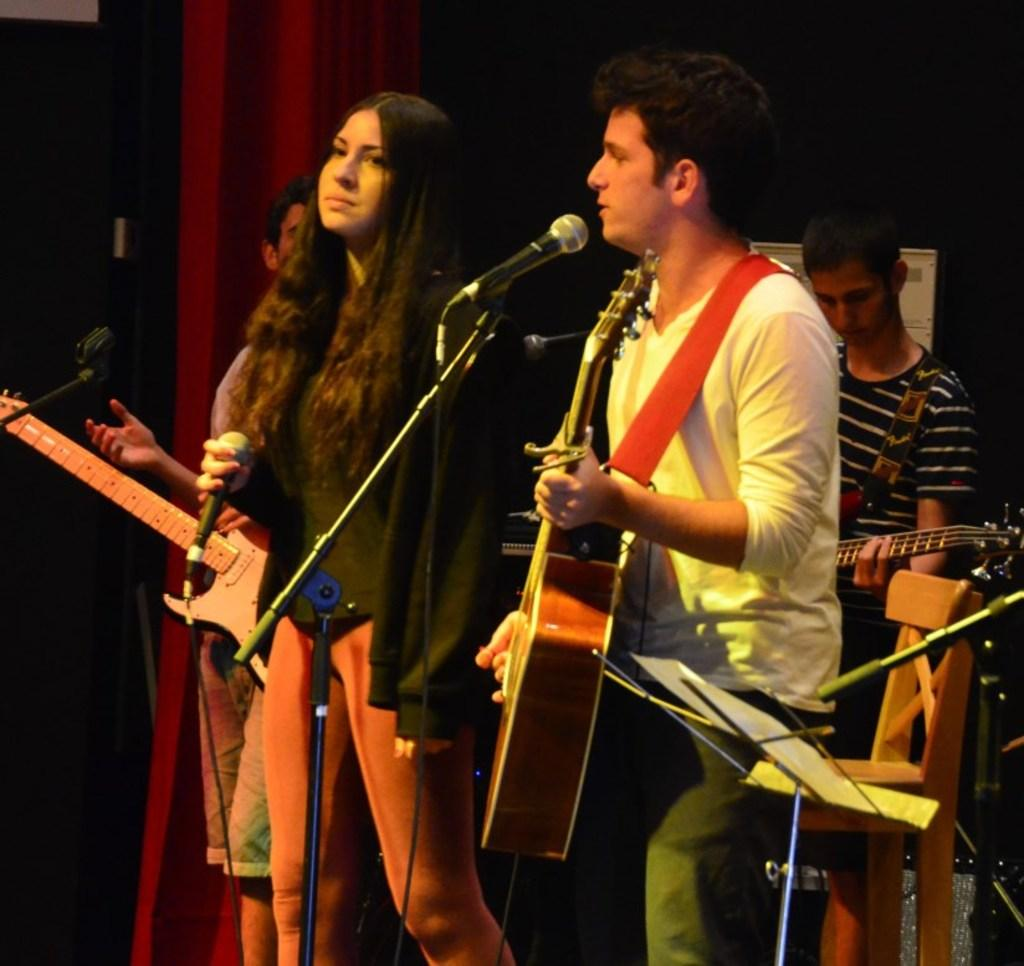What is the main subject of the image? The main subject of the image is a group of people. Can you describe the man in the group? The man in the group is standing and holding a guitar. What is the woman in the group holding? The woman in the group is holding a microphone. What object can be seen on the right side of the image? There is a chair on the right side of the image. How many centimeters of cork are visible in the image? There is no cork present in the image. What effect does the music have on the people in the image? The image does not show any music being played or any effect it might have on the people. 